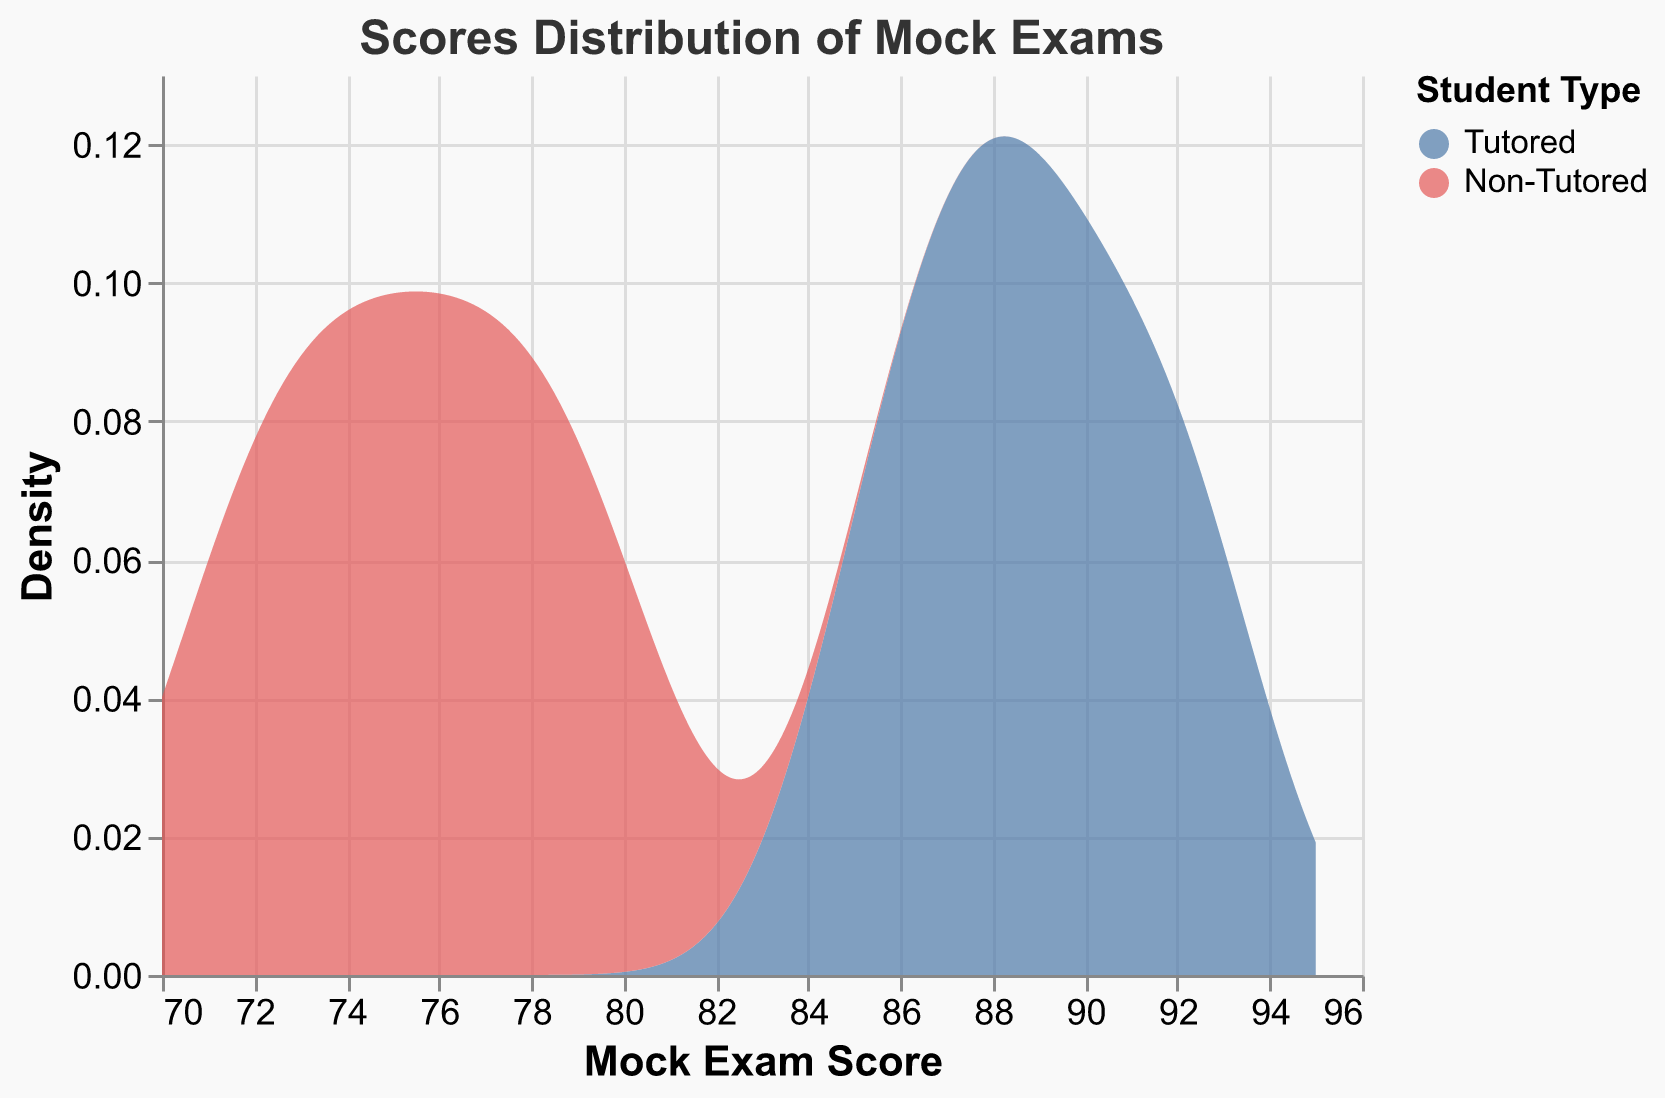What's the title of the figure? The title is typically displayed at the top of the figure and provides a summary of what the plot represents. In this case, it describes the distribution of mock exam scores.
Answer: Scores Distribution of Mock Exams What are the two colors used in the plot to represent different student types? The two colors visually distinguish between tutored and non-tutored students. Tutored students are usually represented in blue while non-tutored students in red.
Answer: Blue and Red Which student group has a higher density of scores around 85? Density in the plot indicates the concentration of values. By observing the peaks, we can determine which group is more concentrated around that score.
Answer: Tutored What is the score range depicted on the x-axis? The x-axis range is defined by the lowest and highest scores, indicating the span of mock exam scores being analyzed.
Answer: 70 to 95 Which group's density curve shows a higher peak? The height of the density curve peak indicates the group with more concentrated scores in a specific interval. By comparing the peaks of both curves, we deduce this information.
Answer: Tutored What is the median score for the Non-Tutored group? To find the median score of Non-Tutored students, list their scores in ascending order: 71, 72, 73, 74, 75, 76, 77, 78, 79, 80. The median is the middle value or the average of the two middle values.
Answer: 75.5 How does the density distribution for Tutored students compare to Non-Tutored students? Comparing density curves helps us understand score distributions. Tutored students' scores are more concentrated around higher values, showing the impact of tutoring.
Answer: Tutored students have higher scores What can be inferred about the effectiveness of tutoring based on the plot? The plot illustrates two groups' score distributions. A higher density of higher scores in the tutored group implies better performance, suggesting tutoring's positive impact.
Answer: Tutoring is effective Which student group has a wider score distribution? The width of the density curve on the x-axis indicates score spread. By comparing both curves' ranges, we determine the wider distribution.
Answer: Non-Tutored Describe the separation between the two groups in terms of score density. By observing the density curves' overlap and peak positions, we see how distinct the score distributions are between tutored and non-tutored students.
Answer: Tutored and Non-Tutored are well-separated, with Tutored scores higher 